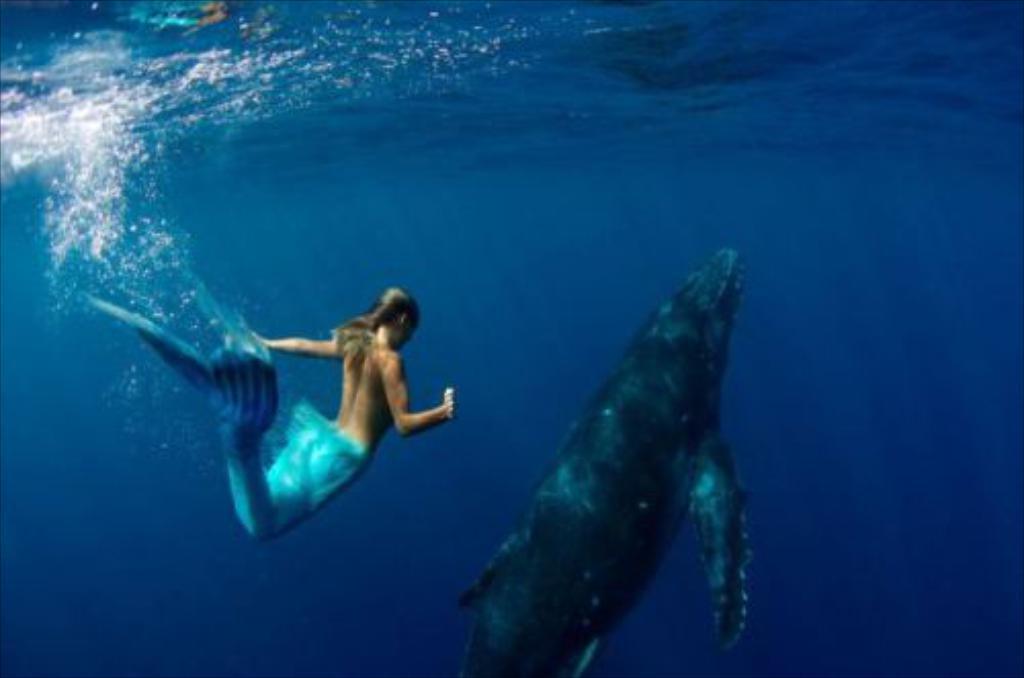How would you summarize this image in a sentence or two? In the image we can see water, in the water we can see a fish and mermaid. 